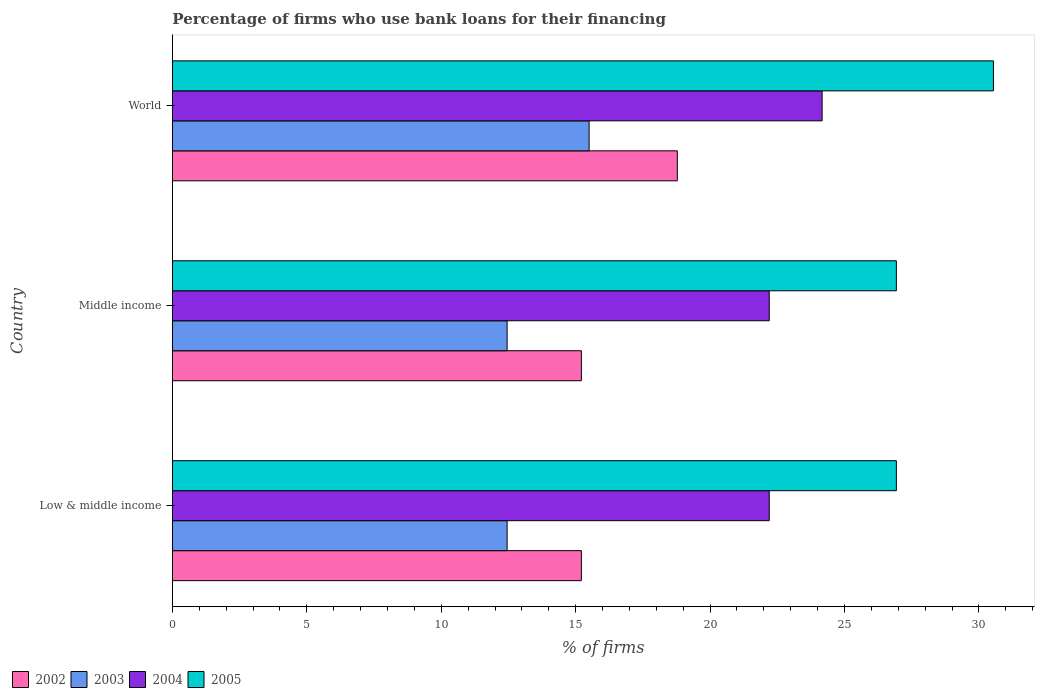How many different coloured bars are there?
Your answer should be compact. 4. How many groups of bars are there?
Your answer should be very brief. 3. Are the number of bars per tick equal to the number of legend labels?
Offer a very short reply. Yes. Are the number of bars on each tick of the Y-axis equal?
Keep it short and to the point. Yes. How many bars are there on the 2nd tick from the bottom?
Ensure brevity in your answer.  4. What is the percentage of firms who use bank loans for their financing in 2005 in World?
Keep it short and to the point. 30.54. Across all countries, what is the maximum percentage of firms who use bank loans for their financing in 2004?
Your answer should be very brief. 24.17. Across all countries, what is the minimum percentage of firms who use bank loans for their financing in 2005?
Keep it short and to the point. 26.93. In which country was the percentage of firms who use bank loans for their financing in 2003 maximum?
Keep it short and to the point. World. In which country was the percentage of firms who use bank loans for their financing in 2004 minimum?
Give a very brief answer. Low & middle income. What is the total percentage of firms who use bank loans for their financing in 2004 in the graph?
Your answer should be very brief. 68.57. What is the difference between the percentage of firms who use bank loans for their financing in 2003 in Middle income and that in World?
Offer a very short reply. -3.05. What is the difference between the percentage of firms who use bank loans for their financing in 2004 in Middle income and the percentage of firms who use bank loans for their financing in 2003 in Low & middle income?
Make the answer very short. 9.75. What is the average percentage of firms who use bank loans for their financing in 2005 per country?
Give a very brief answer. 28.13. What is the difference between the percentage of firms who use bank loans for their financing in 2004 and percentage of firms who use bank loans for their financing in 2005 in Low & middle income?
Keep it short and to the point. -4.73. What is the ratio of the percentage of firms who use bank loans for their financing in 2002 in Low & middle income to that in Middle income?
Offer a terse response. 1. What is the difference between the highest and the second highest percentage of firms who use bank loans for their financing in 2005?
Provide a succinct answer. 3.61. What is the difference between the highest and the lowest percentage of firms who use bank loans for their financing in 2005?
Keep it short and to the point. 3.61. In how many countries, is the percentage of firms who use bank loans for their financing in 2003 greater than the average percentage of firms who use bank loans for their financing in 2003 taken over all countries?
Offer a terse response. 1. Are all the bars in the graph horizontal?
Offer a very short reply. Yes. How many countries are there in the graph?
Your answer should be very brief. 3. Are the values on the major ticks of X-axis written in scientific E-notation?
Give a very brief answer. No. Does the graph contain any zero values?
Provide a short and direct response. No. How many legend labels are there?
Offer a very short reply. 4. How are the legend labels stacked?
Keep it short and to the point. Horizontal. What is the title of the graph?
Ensure brevity in your answer.  Percentage of firms who use bank loans for their financing. What is the label or title of the X-axis?
Keep it short and to the point. % of firms. What is the label or title of the Y-axis?
Provide a succinct answer. Country. What is the % of firms in 2002 in Low & middle income?
Keep it short and to the point. 15.21. What is the % of firms in 2003 in Low & middle income?
Your answer should be very brief. 12.45. What is the % of firms in 2004 in Low & middle income?
Ensure brevity in your answer.  22.2. What is the % of firms in 2005 in Low & middle income?
Offer a very short reply. 26.93. What is the % of firms in 2002 in Middle income?
Keep it short and to the point. 15.21. What is the % of firms of 2003 in Middle income?
Make the answer very short. 12.45. What is the % of firms of 2005 in Middle income?
Your response must be concise. 26.93. What is the % of firms of 2002 in World?
Offer a very short reply. 18.78. What is the % of firms in 2004 in World?
Keep it short and to the point. 24.17. What is the % of firms in 2005 in World?
Provide a succinct answer. 30.54. Across all countries, what is the maximum % of firms in 2002?
Keep it short and to the point. 18.78. Across all countries, what is the maximum % of firms of 2004?
Give a very brief answer. 24.17. Across all countries, what is the maximum % of firms of 2005?
Give a very brief answer. 30.54. Across all countries, what is the minimum % of firms in 2002?
Offer a very short reply. 15.21. Across all countries, what is the minimum % of firms in 2003?
Make the answer very short. 12.45. Across all countries, what is the minimum % of firms of 2005?
Your answer should be compact. 26.93. What is the total % of firms of 2002 in the graph?
Offer a terse response. 49.21. What is the total % of firms of 2003 in the graph?
Give a very brief answer. 40.4. What is the total % of firms in 2004 in the graph?
Ensure brevity in your answer.  68.57. What is the total % of firms of 2005 in the graph?
Your response must be concise. 84.39. What is the difference between the % of firms in 2003 in Low & middle income and that in Middle income?
Provide a succinct answer. 0. What is the difference between the % of firms of 2002 in Low & middle income and that in World?
Your answer should be compact. -3.57. What is the difference between the % of firms in 2003 in Low & middle income and that in World?
Provide a short and direct response. -3.05. What is the difference between the % of firms in 2004 in Low & middle income and that in World?
Your response must be concise. -1.97. What is the difference between the % of firms in 2005 in Low & middle income and that in World?
Your answer should be compact. -3.61. What is the difference between the % of firms of 2002 in Middle income and that in World?
Keep it short and to the point. -3.57. What is the difference between the % of firms of 2003 in Middle income and that in World?
Offer a very short reply. -3.05. What is the difference between the % of firms in 2004 in Middle income and that in World?
Provide a succinct answer. -1.97. What is the difference between the % of firms of 2005 in Middle income and that in World?
Give a very brief answer. -3.61. What is the difference between the % of firms of 2002 in Low & middle income and the % of firms of 2003 in Middle income?
Give a very brief answer. 2.76. What is the difference between the % of firms in 2002 in Low & middle income and the % of firms in 2004 in Middle income?
Your response must be concise. -6.99. What is the difference between the % of firms in 2002 in Low & middle income and the % of firms in 2005 in Middle income?
Provide a short and direct response. -11.72. What is the difference between the % of firms of 2003 in Low & middle income and the % of firms of 2004 in Middle income?
Offer a very short reply. -9.75. What is the difference between the % of firms of 2003 in Low & middle income and the % of firms of 2005 in Middle income?
Make the answer very short. -14.48. What is the difference between the % of firms of 2004 in Low & middle income and the % of firms of 2005 in Middle income?
Offer a terse response. -4.73. What is the difference between the % of firms in 2002 in Low & middle income and the % of firms in 2003 in World?
Your response must be concise. -0.29. What is the difference between the % of firms of 2002 in Low & middle income and the % of firms of 2004 in World?
Offer a very short reply. -8.95. What is the difference between the % of firms in 2002 in Low & middle income and the % of firms in 2005 in World?
Your answer should be very brief. -15.33. What is the difference between the % of firms in 2003 in Low & middle income and the % of firms in 2004 in World?
Provide a short and direct response. -11.72. What is the difference between the % of firms of 2003 in Low & middle income and the % of firms of 2005 in World?
Ensure brevity in your answer.  -18.09. What is the difference between the % of firms of 2004 in Low & middle income and the % of firms of 2005 in World?
Provide a succinct answer. -8.34. What is the difference between the % of firms in 2002 in Middle income and the % of firms in 2003 in World?
Give a very brief answer. -0.29. What is the difference between the % of firms of 2002 in Middle income and the % of firms of 2004 in World?
Keep it short and to the point. -8.95. What is the difference between the % of firms of 2002 in Middle income and the % of firms of 2005 in World?
Give a very brief answer. -15.33. What is the difference between the % of firms of 2003 in Middle income and the % of firms of 2004 in World?
Your answer should be compact. -11.72. What is the difference between the % of firms in 2003 in Middle income and the % of firms in 2005 in World?
Give a very brief answer. -18.09. What is the difference between the % of firms in 2004 in Middle income and the % of firms in 2005 in World?
Provide a short and direct response. -8.34. What is the average % of firms in 2002 per country?
Your response must be concise. 16.4. What is the average % of firms in 2003 per country?
Offer a very short reply. 13.47. What is the average % of firms in 2004 per country?
Give a very brief answer. 22.86. What is the average % of firms of 2005 per country?
Your response must be concise. 28.13. What is the difference between the % of firms in 2002 and % of firms in 2003 in Low & middle income?
Your response must be concise. 2.76. What is the difference between the % of firms in 2002 and % of firms in 2004 in Low & middle income?
Offer a very short reply. -6.99. What is the difference between the % of firms in 2002 and % of firms in 2005 in Low & middle income?
Ensure brevity in your answer.  -11.72. What is the difference between the % of firms of 2003 and % of firms of 2004 in Low & middle income?
Give a very brief answer. -9.75. What is the difference between the % of firms of 2003 and % of firms of 2005 in Low & middle income?
Your answer should be compact. -14.48. What is the difference between the % of firms of 2004 and % of firms of 2005 in Low & middle income?
Make the answer very short. -4.73. What is the difference between the % of firms of 2002 and % of firms of 2003 in Middle income?
Your answer should be very brief. 2.76. What is the difference between the % of firms of 2002 and % of firms of 2004 in Middle income?
Provide a short and direct response. -6.99. What is the difference between the % of firms in 2002 and % of firms in 2005 in Middle income?
Your answer should be very brief. -11.72. What is the difference between the % of firms in 2003 and % of firms in 2004 in Middle income?
Your answer should be compact. -9.75. What is the difference between the % of firms in 2003 and % of firms in 2005 in Middle income?
Keep it short and to the point. -14.48. What is the difference between the % of firms in 2004 and % of firms in 2005 in Middle income?
Give a very brief answer. -4.73. What is the difference between the % of firms in 2002 and % of firms in 2003 in World?
Your answer should be compact. 3.28. What is the difference between the % of firms in 2002 and % of firms in 2004 in World?
Provide a succinct answer. -5.39. What is the difference between the % of firms in 2002 and % of firms in 2005 in World?
Ensure brevity in your answer.  -11.76. What is the difference between the % of firms of 2003 and % of firms of 2004 in World?
Your answer should be very brief. -8.67. What is the difference between the % of firms in 2003 and % of firms in 2005 in World?
Make the answer very short. -15.04. What is the difference between the % of firms in 2004 and % of firms in 2005 in World?
Offer a terse response. -6.37. What is the ratio of the % of firms of 2003 in Low & middle income to that in Middle income?
Offer a very short reply. 1. What is the ratio of the % of firms in 2004 in Low & middle income to that in Middle income?
Give a very brief answer. 1. What is the ratio of the % of firms in 2005 in Low & middle income to that in Middle income?
Offer a very short reply. 1. What is the ratio of the % of firms of 2002 in Low & middle income to that in World?
Your answer should be compact. 0.81. What is the ratio of the % of firms of 2003 in Low & middle income to that in World?
Keep it short and to the point. 0.8. What is the ratio of the % of firms in 2004 in Low & middle income to that in World?
Give a very brief answer. 0.92. What is the ratio of the % of firms in 2005 in Low & middle income to that in World?
Make the answer very short. 0.88. What is the ratio of the % of firms in 2002 in Middle income to that in World?
Offer a terse response. 0.81. What is the ratio of the % of firms in 2003 in Middle income to that in World?
Offer a very short reply. 0.8. What is the ratio of the % of firms of 2004 in Middle income to that in World?
Your answer should be very brief. 0.92. What is the ratio of the % of firms of 2005 in Middle income to that in World?
Offer a terse response. 0.88. What is the difference between the highest and the second highest % of firms in 2002?
Your answer should be very brief. 3.57. What is the difference between the highest and the second highest % of firms of 2003?
Make the answer very short. 3.05. What is the difference between the highest and the second highest % of firms in 2004?
Your answer should be compact. 1.97. What is the difference between the highest and the second highest % of firms in 2005?
Give a very brief answer. 3.61. What is the difference between the highest and the lowest % of firms in 2002?
Offer a terse response. 3.57. What is the difference between the highest and the lowest % of firms in 2003?
Ensure brevity in your answer.  3.05. What is the difference between the highest and the lowest % of firms of 2004?
Provide a succinct answer. 1.97. What is the difference between the highest and the lowest % of firms in 2005?
Ensure brevity in your answer.  3.61. 